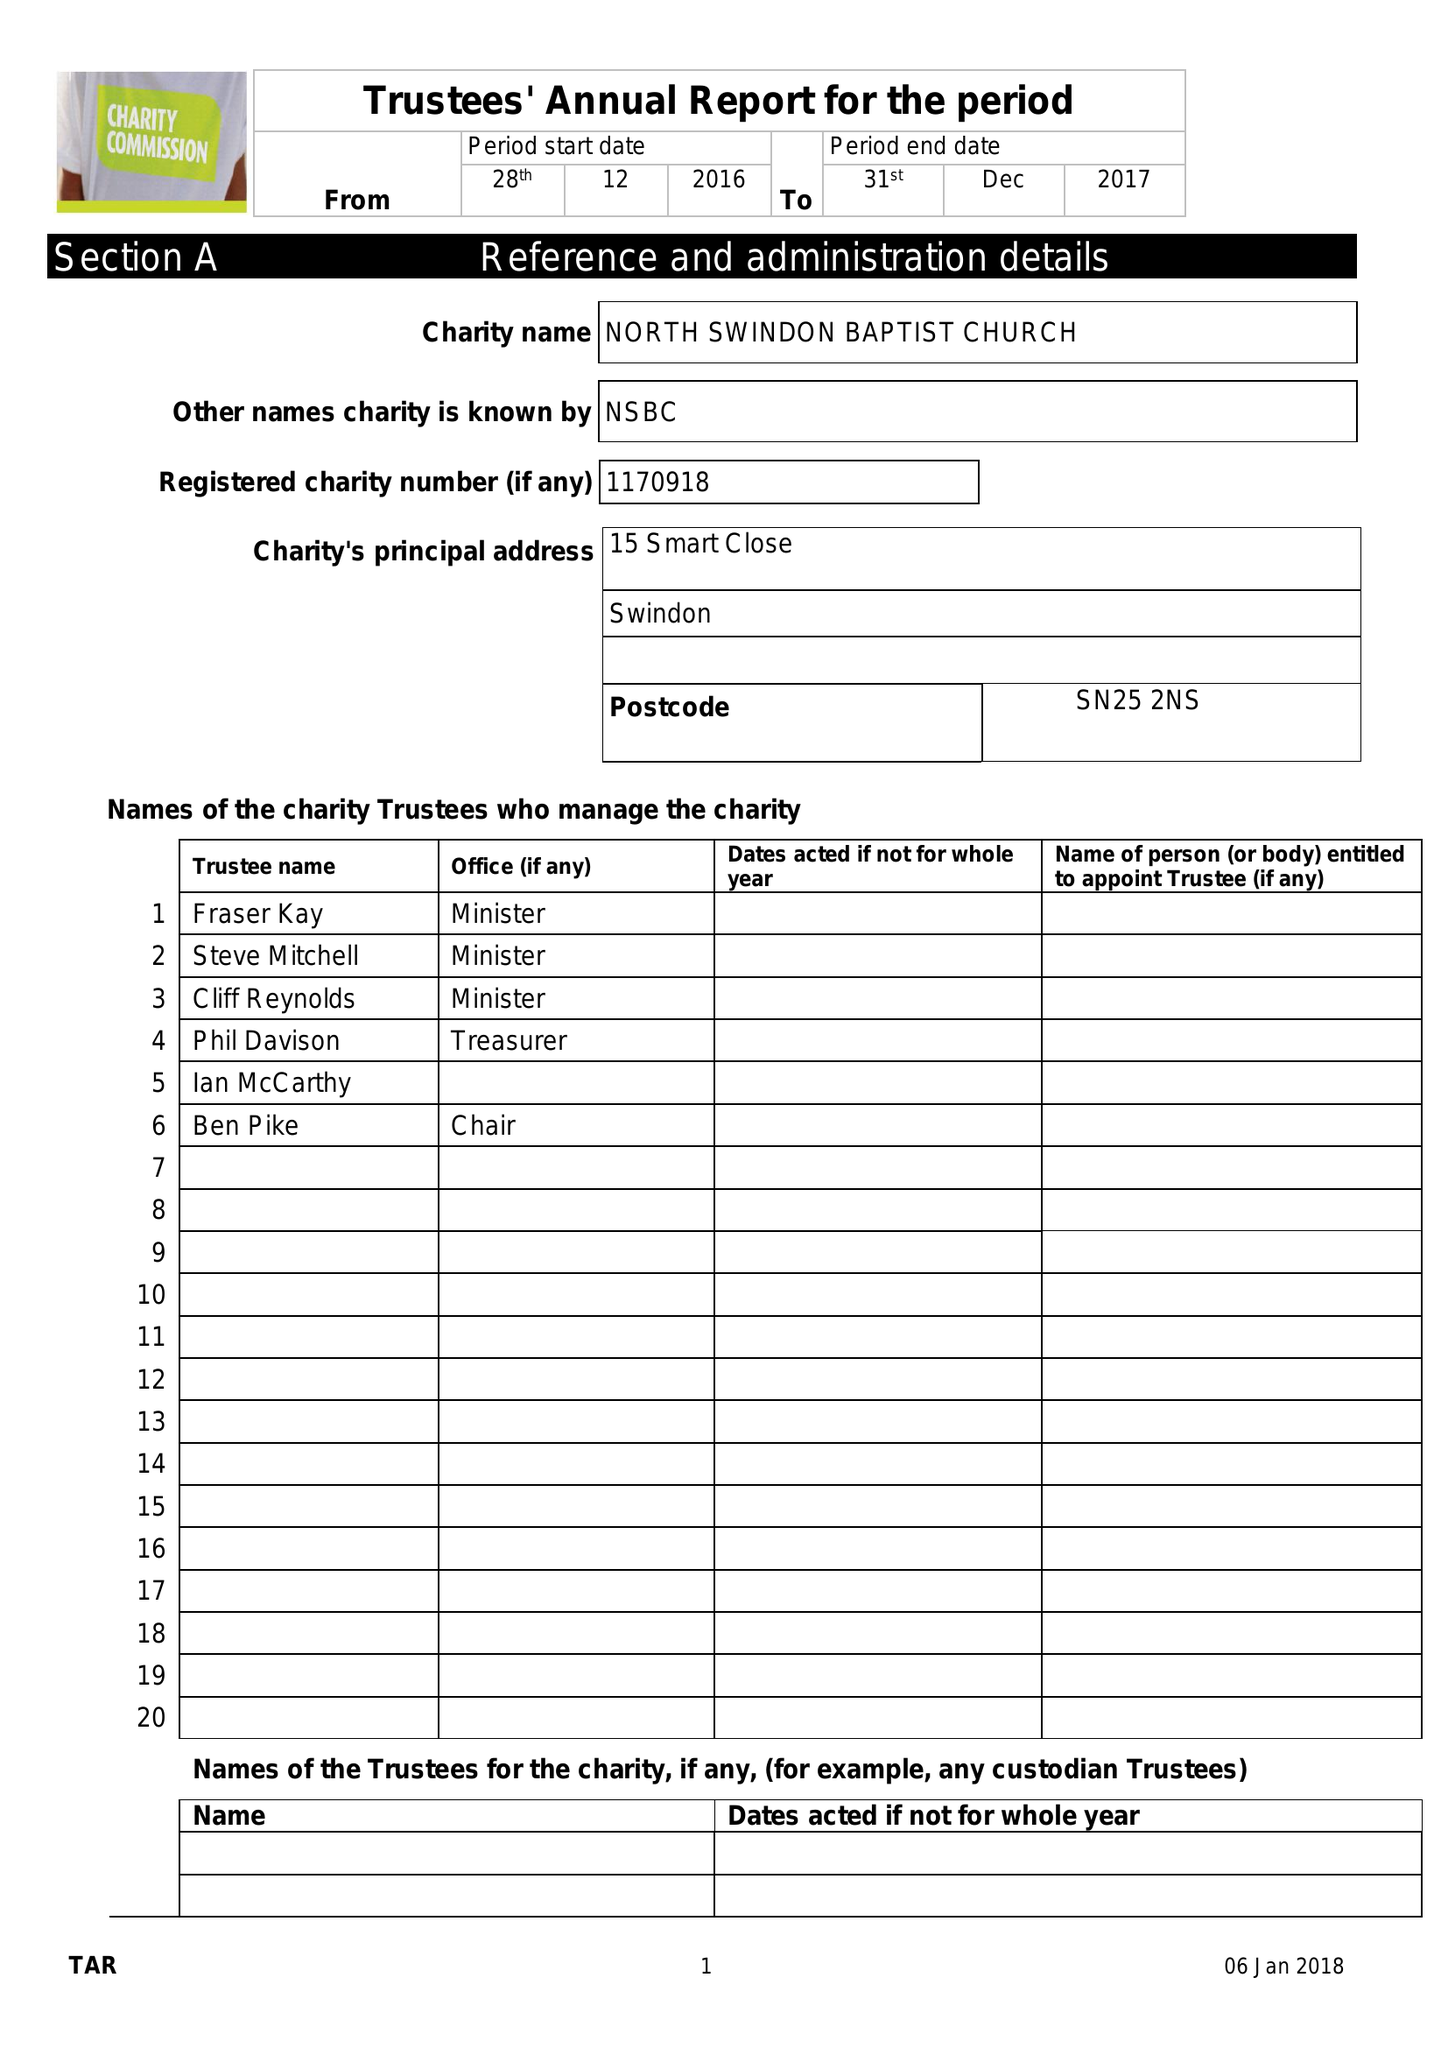What is the value for the report_date?
Answer the question using a single word or phrase. 2017-12-31 